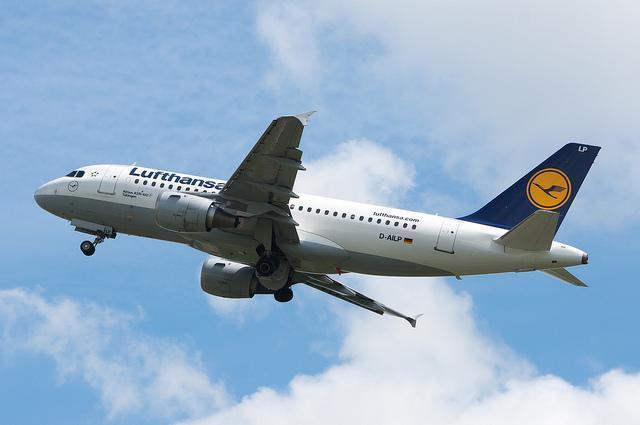How many people are riding on the scooter?
Give a very brief answer. 0. 